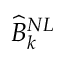Convert formula to latex. <formula><loc_0><loc_0><loc_500><loc_500>\widehat { B } _ { k } ^ { N L }</formula> 